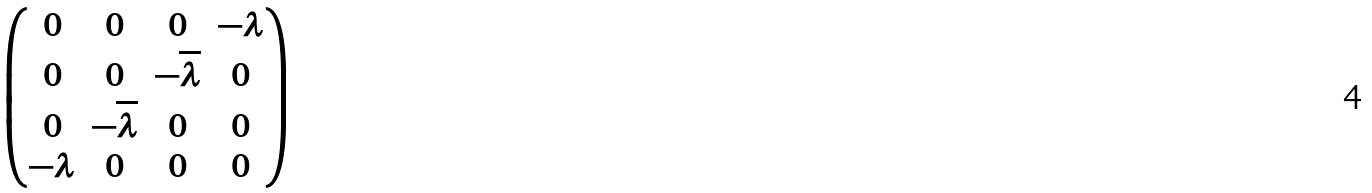<formula> <loc_0><loc_0><loc_500><loc_500>\begin{pmatrix} 0 & 0 & 0 & - \lambda \\ 0 & 0 & - \overline { \lambda } & 0 \\ 0 & - \overline { \lambda } & 0 & 0 \\ - \lambda & 0 & 0 & 0 \end{pmatrix}</formula> 